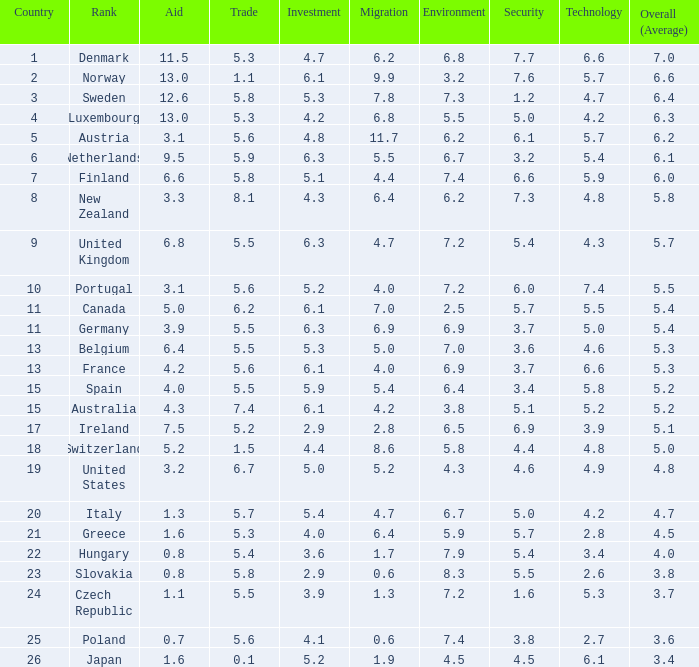How many times is denmark ranked in technological advancements? 1.0. 